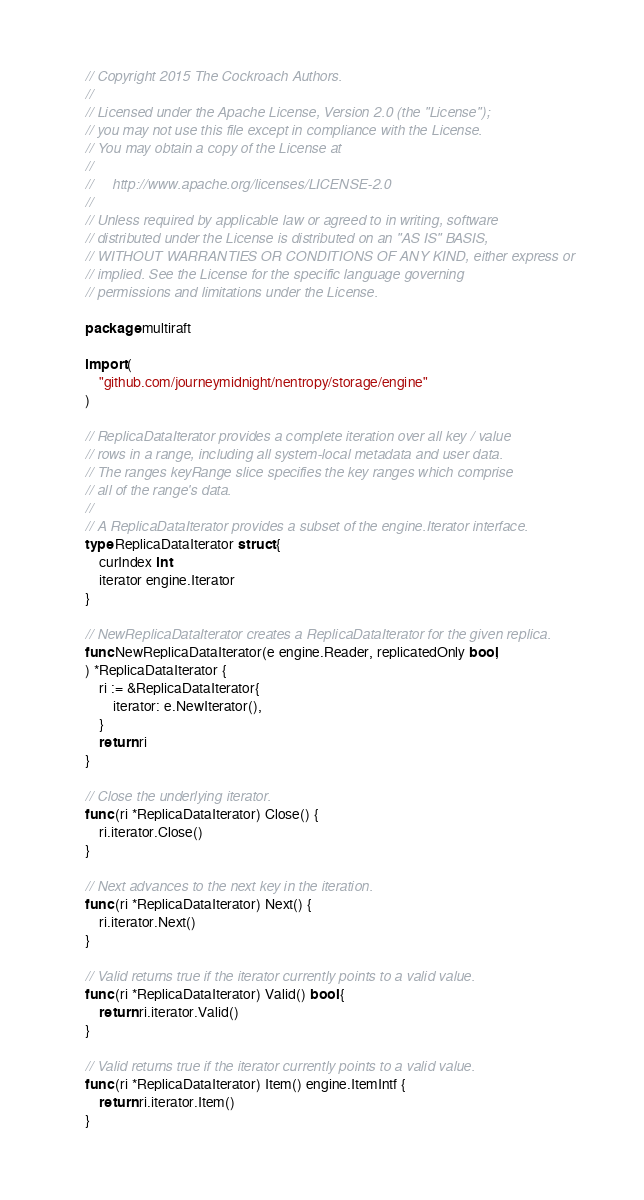Convert code to text. <code><loc_0><loc_0><loc_500><loc_500><_Go_>// Copyright 2015 The Cockroach Authors.
//
// Licensed under the Apache License, Version 2.0 (the "License");
// you may not use this file except in compliance with the License.
// You may obtain a copy of the License at
//
//     http://www.apache.org/licenses/LICENSE-2.0
//
// Unless required by applicable law or agreed to in writing, software
// distributed under the License is distributed on an "AS IS" BASIS,
// WITHOUT WARRANTIES OR CONDITIONS OF ANY KIND, either express or
// implied. See the License for the specific language governing
// permissions and limitations under the License.

package multiraft

import (
	"github.com/journeymidnight/nentropy/storage/engine"
)

// ReplicaDataIterator provides a complete iteration over all key / value
// rows in a range, including all system-local metadata and user data.
// The ranges keyRange slice specifies the key ranges which comprise
// all of the range's data.
//
// A ReplicaDataIterator provides a subset of the engine.Iterator interface.
type ReplicaDataIterator struct {
	curIndex int
	iterator engine.Iterator
}

// NewReplicaDataIterator creates a ReplicaDataIterator for the given replica.
func NewReplicaDataIterator(e engine.Reader, replicatedOnly bool,
) *ReplicaDataIterator {
	ri := &ReplicaDataIterator{
		iterator: e.NewIterator(),
	}
	return ri
}

// Close the underlying iterator.
func (ri *ReplicaDataIterator) Close() {
	ri.iterator.Close()
}

// Next advances to the next key in the iteration.
func (ri *ReplicaDataIterator) Next() {
	ri.iterator.Next()
}

// Valid returns true if the iterator currently points to a valid value.
func (ri *ReplicaDataIterator) Valid() bool {
	return ri.iterator.Valid()
}

// Valid returns true if the iterator currently points to a valid value.
func (ri *ReplicaDataIterator) Item() engine.ItemIntf {
	return ri.iterator.Item()
}
</code> 